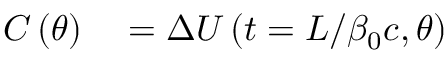<formula> <loc_0><loc_0><loc_500><loc_500>\begin{array} { r l } { C \left ( \theta \right ) } & = \Delta U \left ( t = L / \beta _ { 0 } c , \theta \right ) } \end{array}</formula> 